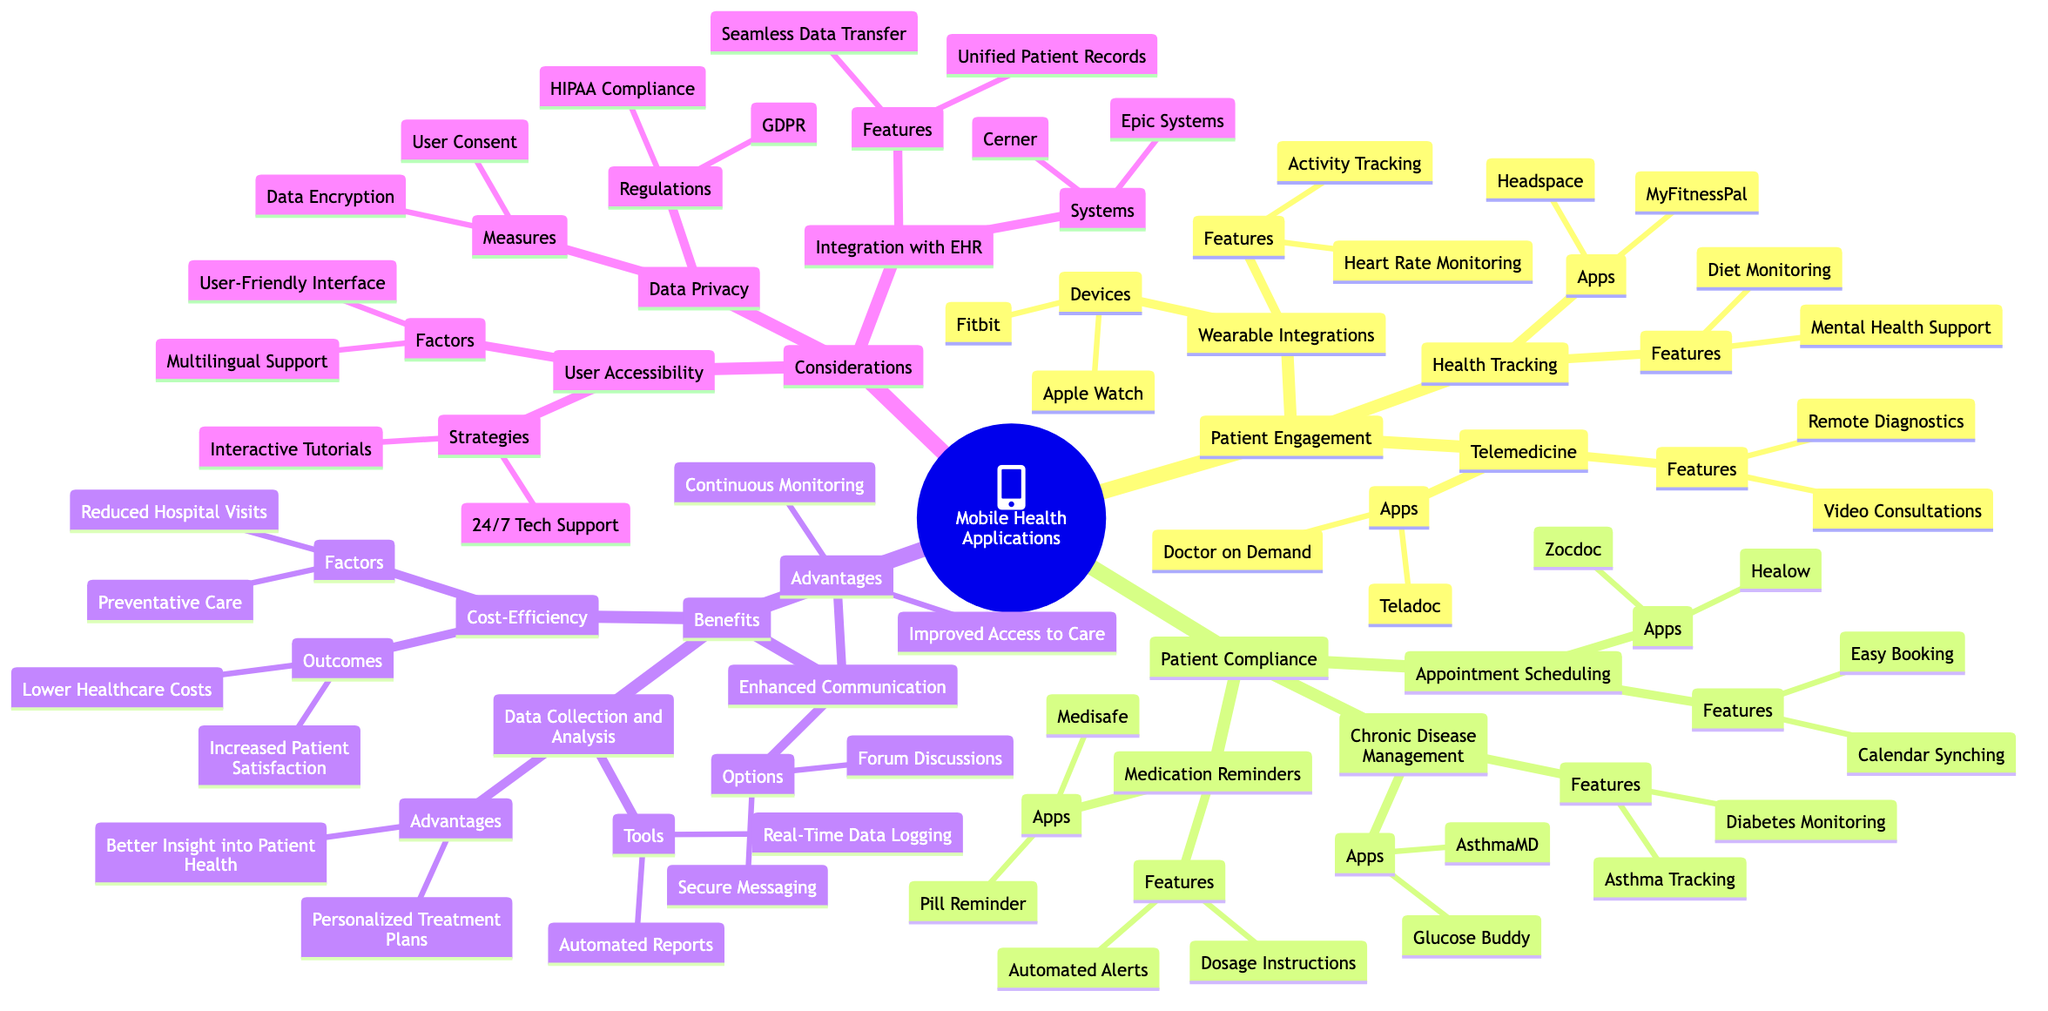What are the two main categories of Mobile Health Applications? The diagram indicates two main categories: Patient Engagement and Patient Compliance. These categories are presented as the first level of branches from the root of the Mind Map.
Answer: Patient Engagement and Patient Compliance Which app is listed under Chronic Disease Management? The diagram enumerates two apps under the Chronic Disease Management category: Glucose Buddy and AsthmaMD. Choosing either of these apps will answer the question.
Answer: Glucose Buddy What feature is associated with Telemedicine apps? The diagram outlines that Telemedicine apps like Teladoc and Doctor on Demand offer features such as Video Consultations and Remote Diagnostics. Either of these features can be considered as a valid answer.
Answer: Video Consultations How many tools are identified under Data Collection and Analysis? The diagram lists two tools under the Data Collection and Analysis category: Real-Time Data Logging and Automated Reports. Counting these tools gives the answer.
Answer: 2 What is a measure taken to ensure Data Privacy? The diagram specifies that Data Encryption is a measure related to Data Privacy in the context of mobile health applications. Thus, this can directly answer the question.
Answer: Data Encryption Which system is mentioned for Integration with EHR? The diagram presents Epic Systems and Cerner as the systems associated with Integration with EHR. The question can be addressed by naming either of the systems.
Answer: Epic Systems What factor contributes to Cost-Efficiency? Under the Cost-Efficiency category, Reduced Hospital Visits is listed as one of the factors, thus serving as a suitable answer to the question.
Answer: Reduced Hospital Visits What advantage does Enhanced Communication provide? The diagram states that Improved Access to Care is one of the advantages resulting from Enhanced Communication options like Secure Messaging and Forum Discussions. This directly answers the question posed.
Answer: Improved Access to Care 